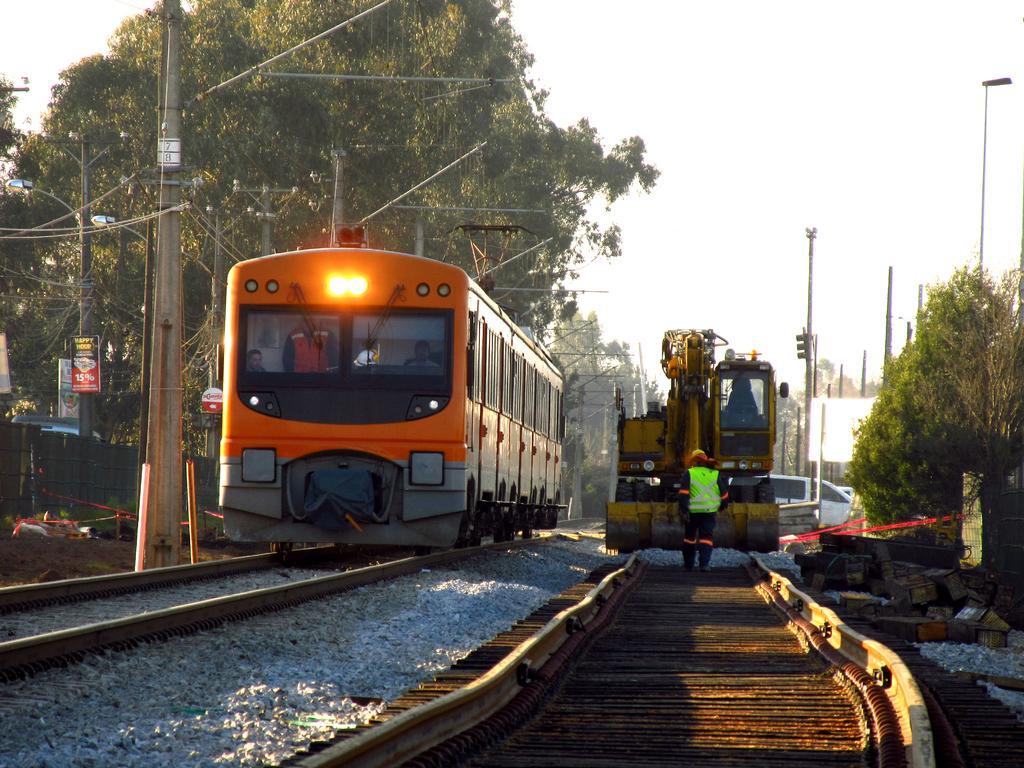In one or two sentences, can you explain what this image depicts? In this image we can see a train on the track and there is a crane. We can see a man. At the bottom there are railway tracks and stones. In the background there are poles, wires, trees and sky. 